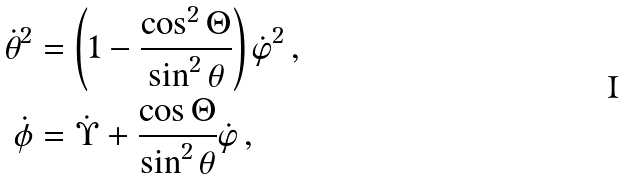<formula> <loc_0><loc_0><loc_500><loc_500>\dot { \theta } ^ { 2 } & = \left ( 1 - \frac { \cos ^ { 2 } \Theta } { \sin ^ { 2 } \theta } \right ) { \dot { \varphi } } ^ { 2 } \, , \\ \dot { \phi } & = \dot { \Upsilon } + \frac { \cos \Theta } { \sin ^ { 2 } \theta } \dot { \varphi } \, ,</formula> 